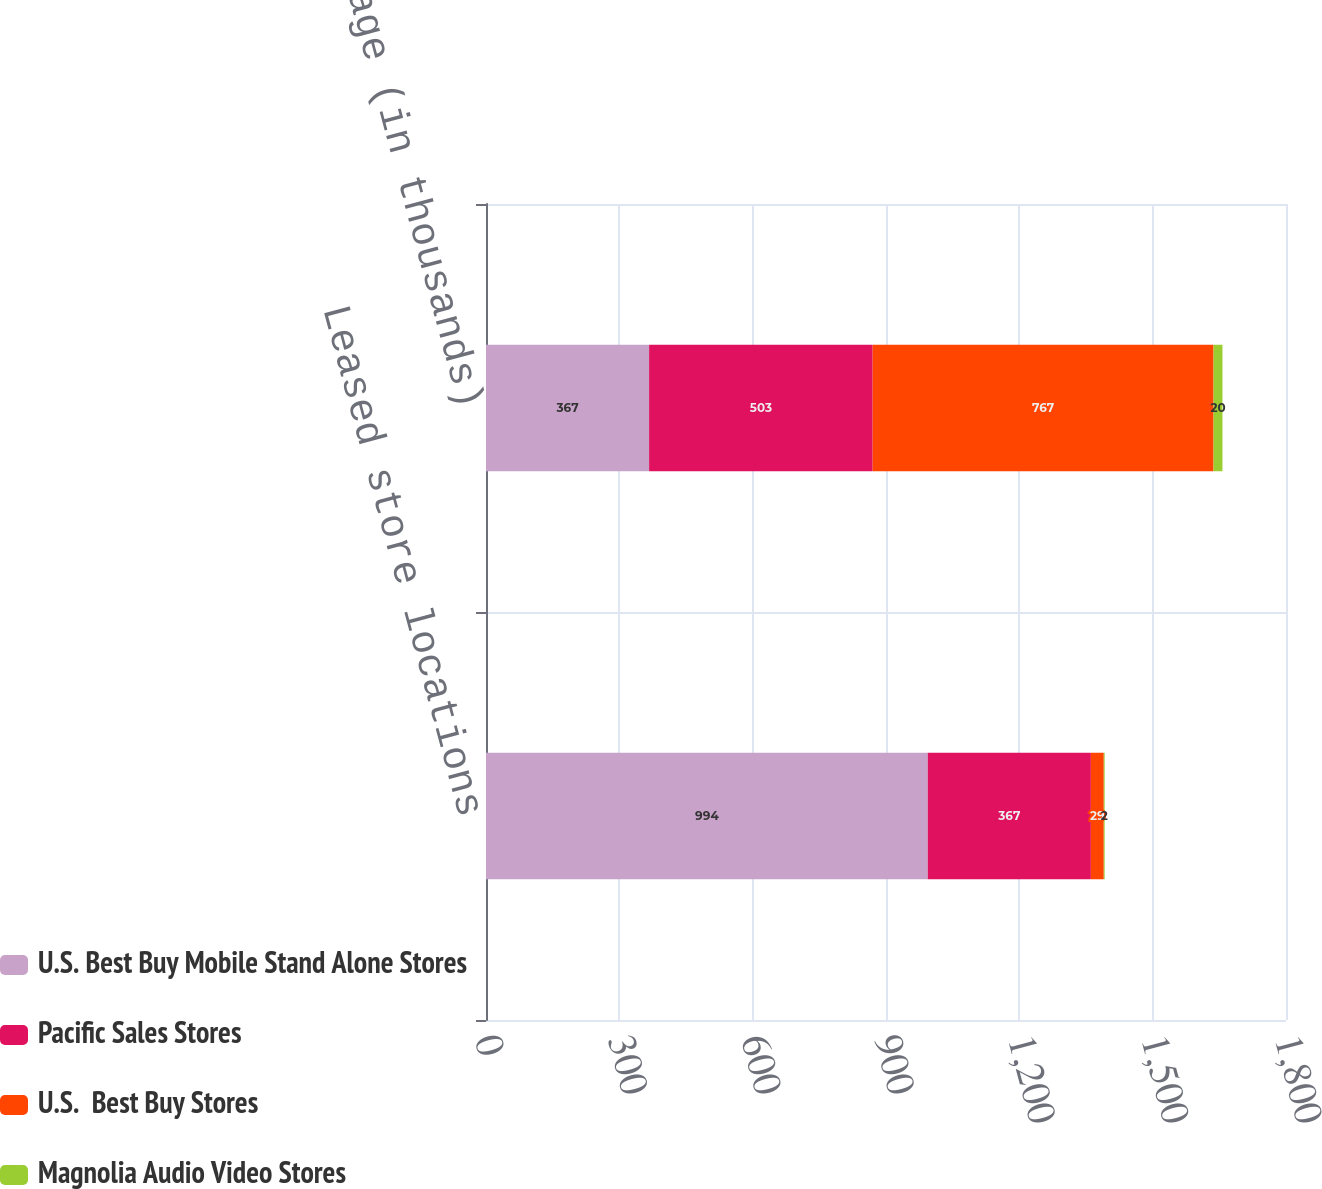Convert chart. <chart><loc_0><loc_0><loc_500><loc_500><stacked_bar_chart><ecel><fcel>Leased store locations<fcel>Square footage (in thousands)<nl><fcel>U.S. Best Buy Mobile Stand Alone Stores<fcel>994<fcel>367<nl><fcel>Pacific Sales Stores<fcel>367<fcel>503<nl><fcel>U.S.  Best Buy Stores<fcel>29<fcel>767<nl><fcel>Magnolia Audio Video Stores<fcel>2<fcel>20<nl></chart> 